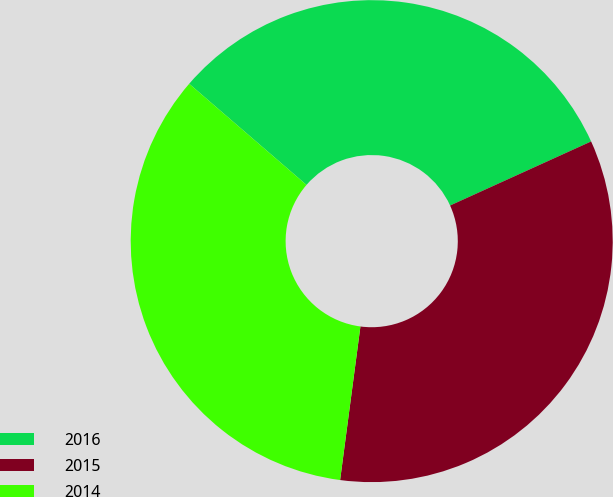Convert chart. <chart><loc_0><loc_0><loc_500><loc_500><pie_chart><fcel>2016<fcel>2015<fcel>2014<nl><fcel>31.89%<fcel>33.88%<fcel>34.23%<nl></chart> 